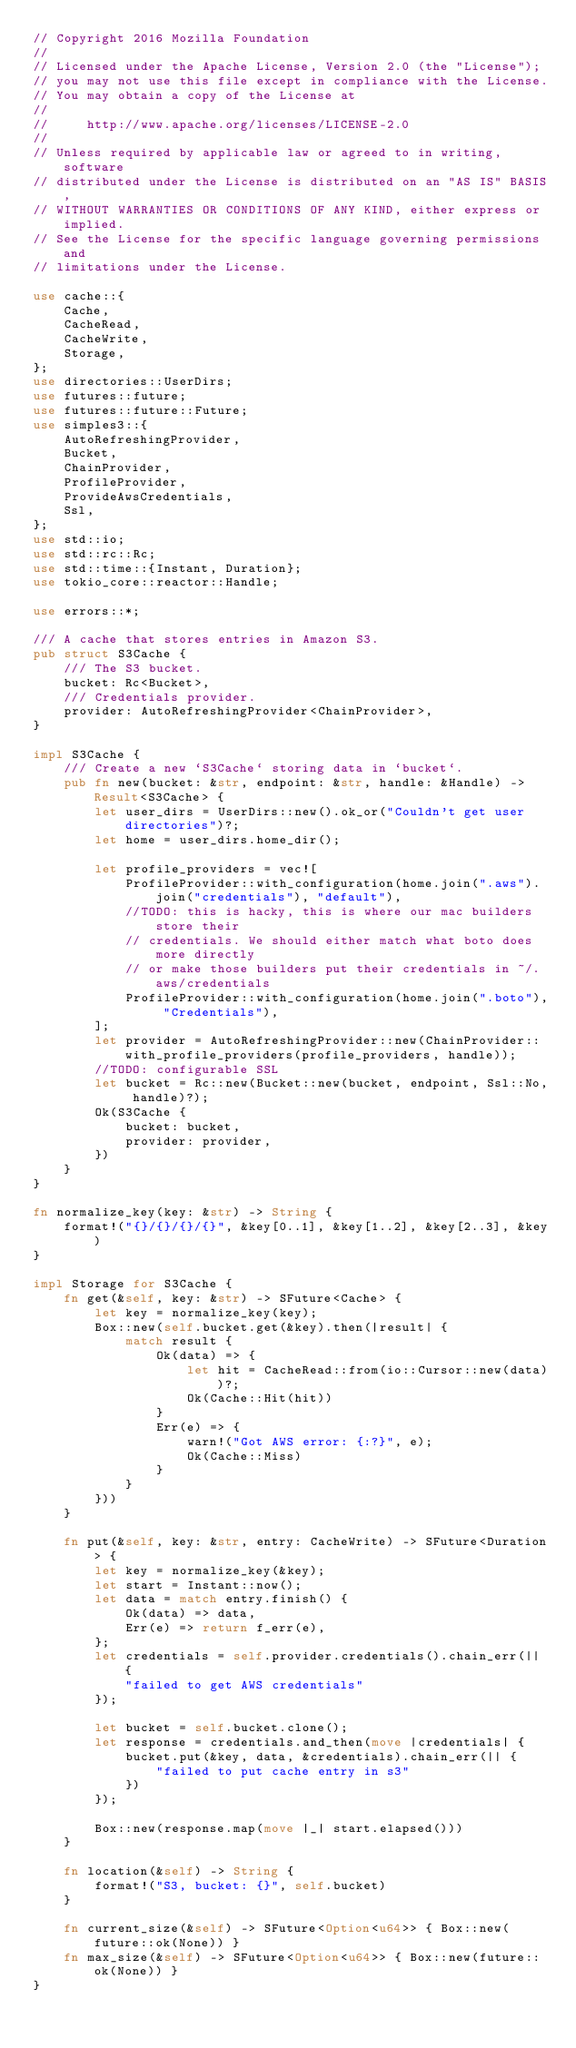<code> <loc_0><loc_0><loc_500><loc_500><_Rust_>// Copyright 2016 Mozilla Foundation
//
// Licensed under the Apache License, Version 2.0 (the "License");
// you may not use this file except in compliance with the License.
// You may obtain a copy of the License at
//
//     http://www.apache.org/licenses/LICENSE-2.0
//
// Unless required by applicable law or agreed to in writing, software
// distributed under the License is distributed on an "AS IS" BASIS,
// WITHOUT WARRANTIES OR CONDITIONS OF ANY KIND, either express or implied.
// See the License for the specific language governing permissions and
// limitations under the License.

use cache::{
    Cache,
    CacheRead,
    CacheWrite,
    Storage,
};
use directories::UserDirs;
use futures::future;
use futures::future::Future;
use simples3::{
    AutoRefreshingProvider,
    Bucket,
    ChainProvider,
    ProfileProvider,
    ProvideAwsCredentials,
    Ssl,
};
use std::io;
use std::rc::Rc;
use std::time::{Instant, Duration};
use tokio_core::reactor::Handle;

use errors::*;

/// A cache that stores entries in Amazon S3.
pub struct S3Cache {
    /// The S3 bucket.
    bucket: Rc<Bucket>,
    /// Credentials provider.
    provider: AutoRefreshingProvider<ChainProvider>,
}

impl S3Cache {
    /// Create a new `S3Cache` storing data in `bucket`.
    pub fn new(bucket: &str, endpoint: &str, handle: &Handle) -> Result<S3Cache> {
        let user_dirs = UserDirs::new().ok_or("Couldn't get user directories")?;
        let home = user_dirs.home_dir();

        let profile_providers = vec![
            ProfileProvider::with_configuration(home.join(".aws").join("credentials"), "default"),
            //TODO: this is hacky, this is where our mac builders store their
            // credentials. We should either match what boto does more directly
            // or make those builders put their credentials in ~/.aws/credentials
            ProfileProvider::with_configuration(home.join(".boto"), "Credentials"),
        ];
        let provider = AutoRefreshingProvider::new(ChainProvider::with_profile_providers(profile_providers, handle));
        //TODO: configurable SSL
        let bucket = Rc::new(Bucket::new(bucket, endpoint, Ssl::No, handle)?);
        Ok(S3Cache {
            bucket: bucket,
            provider: provider,
        })
    }
}

fn normalize_key(key: &str) -> String {
    format!("{}/{}/{}/{}", &key[0..1], &key[1..2], &key[2..3], &key)
}

impl Storage for S3Cache {
    fn get(&self, key: &str) -> SFuture<Cache> {
        let key = normalize_key(key);
        Box::new(self.bucket.get(&key).then(|result| {
            match result {
                Ok(data) => {
                    let hit = CacheRead::from(io::Cursor::new(data))?;
                    Ok(Cache::Hit(hit))
                }
                Err(e) => {
                    warn!("Got AWS error: {:?}", e);
                    Ok(Cache::Miss)
                }
            }
        }))
    }

    fn put(&self, key: &str, entry: CacheWrite) -> SFuture<Duration> {
        let key = normalize_key(&key);
        let start = Instant::now();
        let data = match entry.finish() {
            Ok(data) => data,
            Err(e) => return f_err(e),
        };
        let credentials = self.provider.credentials().chain_err(|| {
            "failed to get AWS credentials"
        });

        let bucket = self.bucket.clone();
        let response = credentials.and_then(move |credentials| {
            bucket.put(&key, data, &credentials).chain_err(|| {
                "failed to put cache entry in s3"
            })
        });

        Box::new(response.map(move |_| start.elapsed()))
    }

    fn location(&self) -> String {
        format!("S3, bucket: {}", self.bucket)
    }

    fn current_size(&self) -> SFuture<Option<u64>> { Box::new(future::ok(None)) }
    fn max_size(&self) -> SFuture<Option<u64>> { Box::new(future::ok(None)) }
}
</code> 